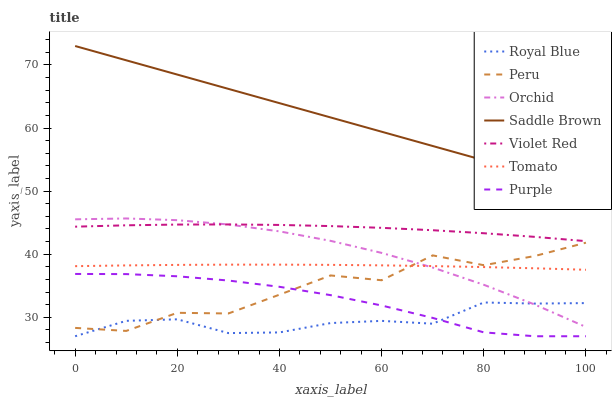Does Royal Blue have the minimum area under the curve?
Answer yes or no. Yes. Does Saddle Brown have the maximum area under the curve?
Answer yes or no. Yes. Does Violet Red have the minimum area under the curve?
Answer yes or no. No. Does Violet Red have the maximum area under the curve?
Answer yes or no. No. Is Saddle Brown the smoothest?
Answer yes or no. Yes. Is Peru the roughest?
Answer yes or no. Yes. Is Violet Red the smoothest?
Answer yes or no. No. Is Violet Red the roughest?
Answer yes or no. No. Does Violet Red have the lowest value?
Answer yes or no. No. Does Saddle Brown have the highest value?
Answer yes or no. Yes. Does Violet Red have the highest value?
Answer yes or no. No. Is Royal Blue less than Saddle Brown?
Answer yes or no. Yes. Is Saddle Brown greater than Orchid?
Answer yes or no. Yes. Does Royal Blue intersect Purple?
Answer yes or no. Yes. Is Royal Blue less than Purple?
Answer yes or no. No. Is Royal Blue greater than Purple?
Answer yes or no. No. Does Royal Blue intersect Saddle Brown?
Answer yes or no. No. 